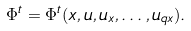Convert formula to latex. <formula><loc_0><loc_0><loc_500><loc_500>\Phi ^ { t } = \Phi ^ { t } ( x , u , u _ { x } , \dots , u _ { q x } ) .</formula> 